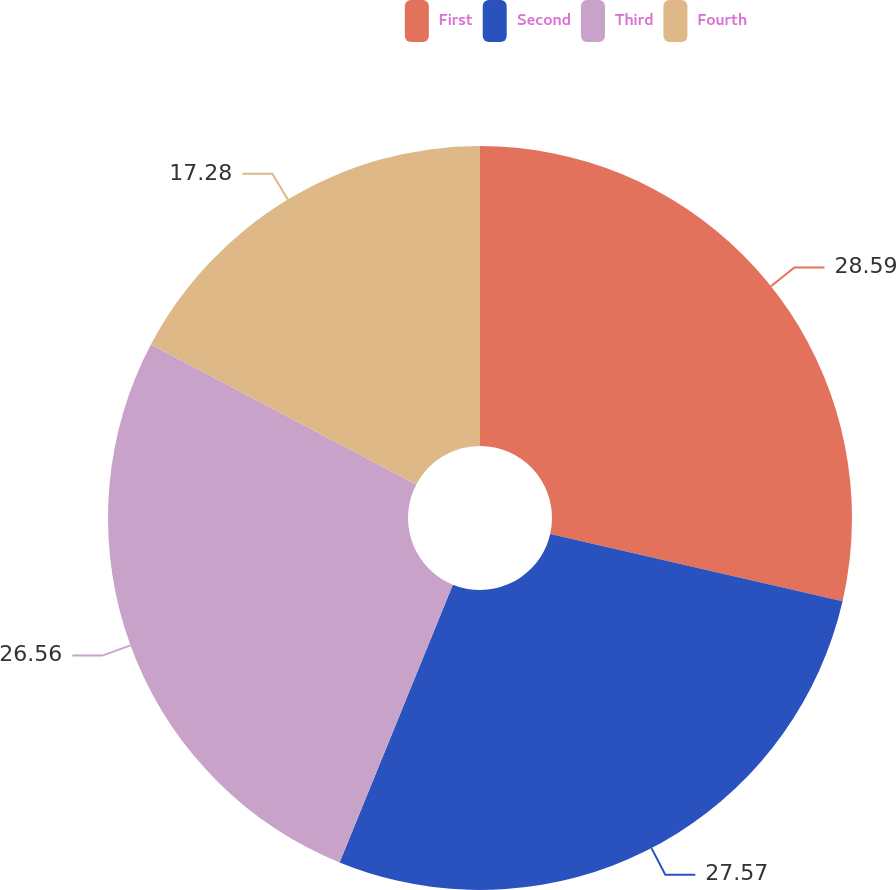Convert chart. <chart><loc_0><loc_0><loc_500><loc_500><pie_chart><fcel>First<fcel>Second<fcel>Third<fcel>Fourth<nl><fcel>28.59%<fcel>27.57%<fcel>26.56%<fcel>17.28%<nl></chart> 